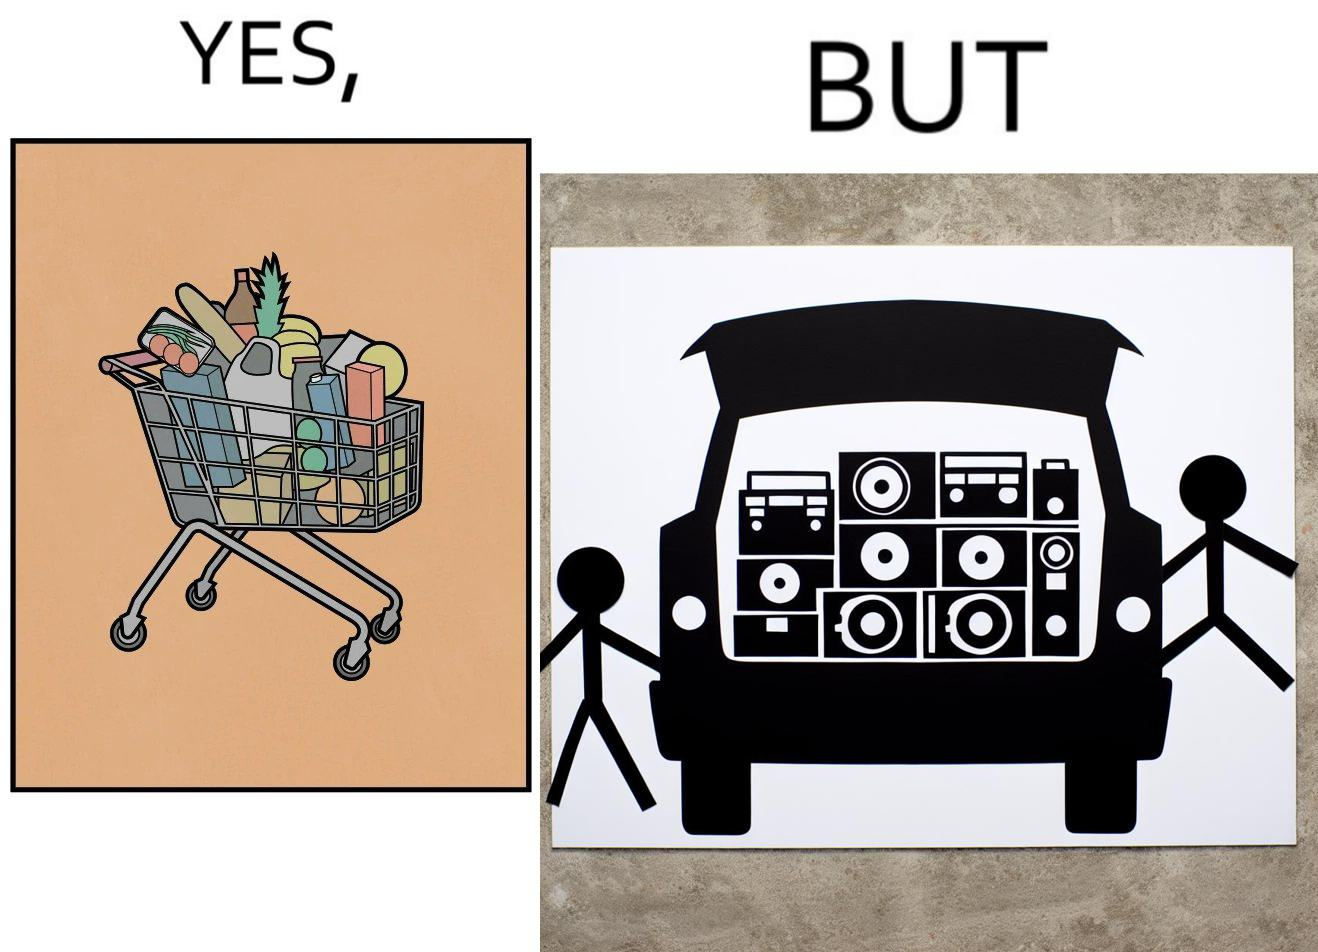What is shown in the left half versus the right half of this image? In the left part of the image: a shopping cart full of items In the right part of the image: a black car with its trunk lid open and some boxes, probably speakers, kept in the trunk 